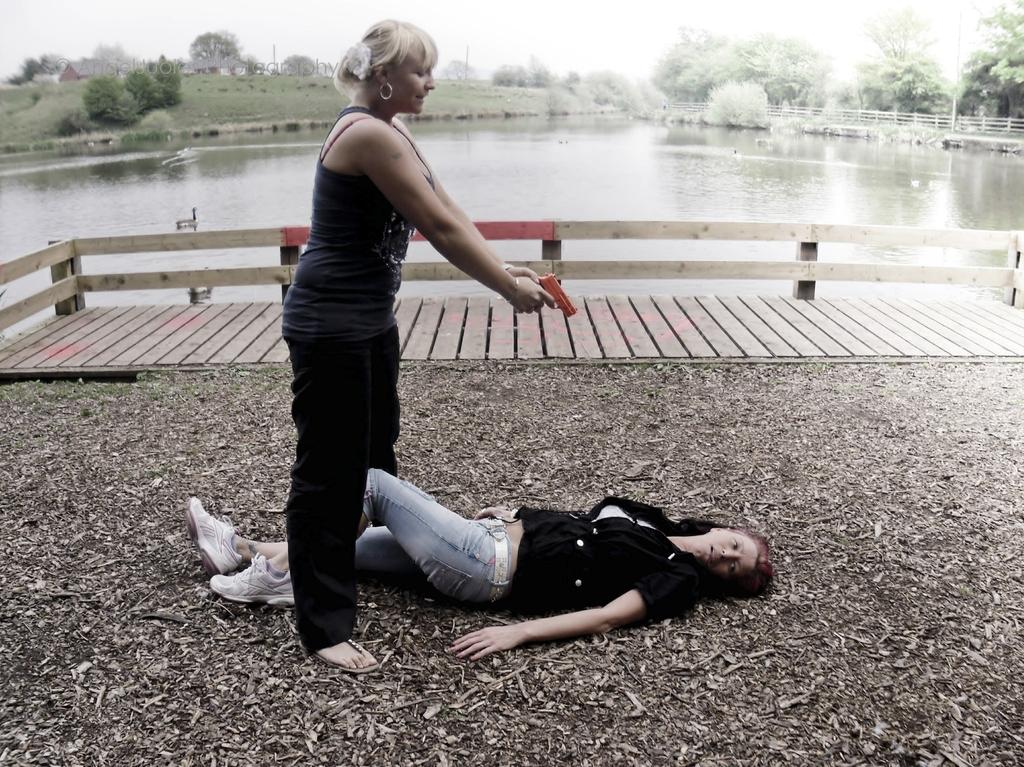How many women are present in the image? There are two women in the image, one standing and one lying on the ground. What is the setting of the image? The image features a woman standing and another lying on the ground, with water, trees, and the sky visible in the background. What can be seen in the background of the image? In the background of the image, there is water, trees, and the sky. What type of cork can be seen floating in the water in the image? There is no cork visible in the water in the image. What song is the woman standing in the image singing? The image does not provide any information about the woman singing a song. 